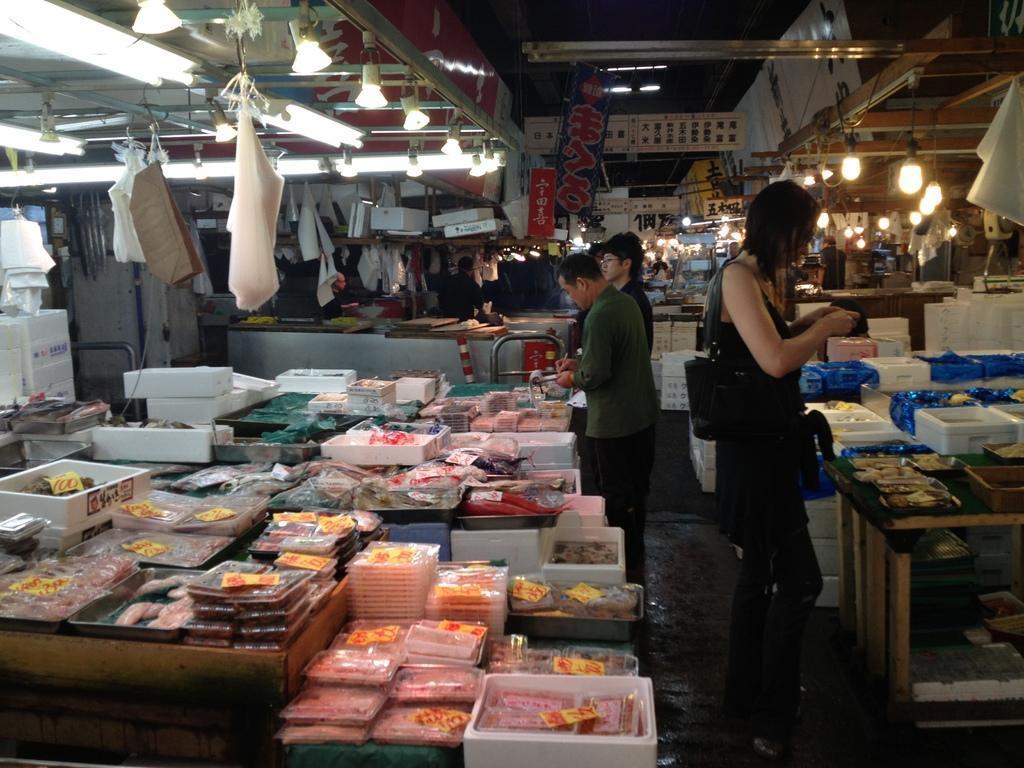Describe this image in one or two sentences. In this image we can see items packed in the cover, boxes and objects on the tables and in the middle there are few persons standing on the floor at the tables. In the background there are cover bags hanging to the poles, lights on the poles, hoardings, objects and a person on the right side. 